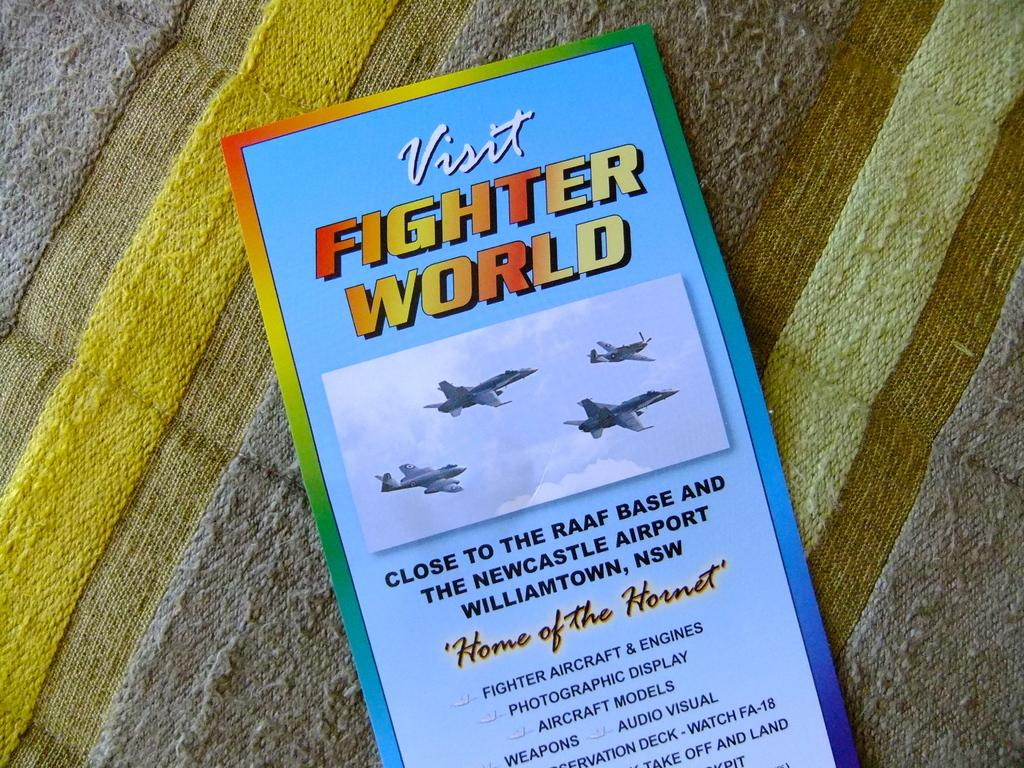Provide a one-sentence caption for the provided image. A brochure that says Visit Fighter World in yellow and red letters with info about it underneath a picture of 4 airplanes. 